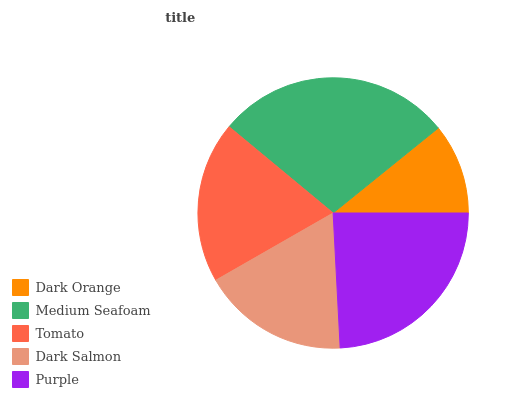Is Dark Orange the minimum?
Answer yes or no. Yes. Is Medium Seafoam the maximum?
Answer yes or no. Yes. Is Tomato the minimum?
Answer yes or no. No. Is Tomato the maximum?
Answer yes or no. No. Is Medium Seafoam greater than Tomato?
Answer yes or no. Yes. Is Tomato less than Medium Seafoam?
Answer yes or no. Yes. Is Tomato greater than Medium Seafoam?
Answer yes or no. No. Is Medium Seafoam less than Tomato?
Answer yes or no. No. Is Tomato the high median?
Answer yes or no. Yes. Is Tomato the low median?
Answer yes or no. Yes. Is Medium Seafoam the high median?
Answer yes or no. No. Is Dark Orange the low median?
Answer yes or no. No. 